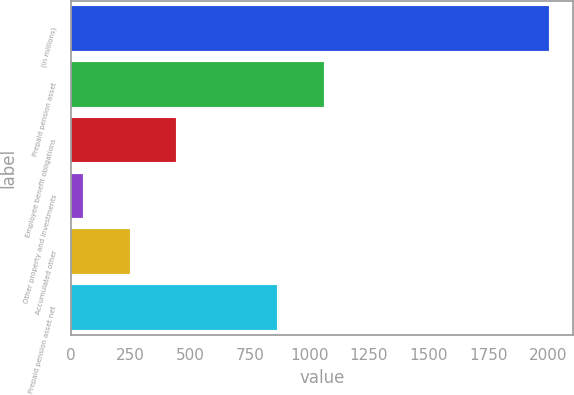<chart> <loc_0><loc_0><loc_500><loc_500><bar_chart><fcel>(in millions)<fcel>Prepaid pension asset<fcel>Employee benefit obligations<fcel>Other property and investments<fcel>Accumulated other<fcel>Prepaid pension asset net<nl><fcel>2004<fcel>1059.4<fcel>440.8<fcel>50<fcel>245.4<fcel>864<nl></chart> 